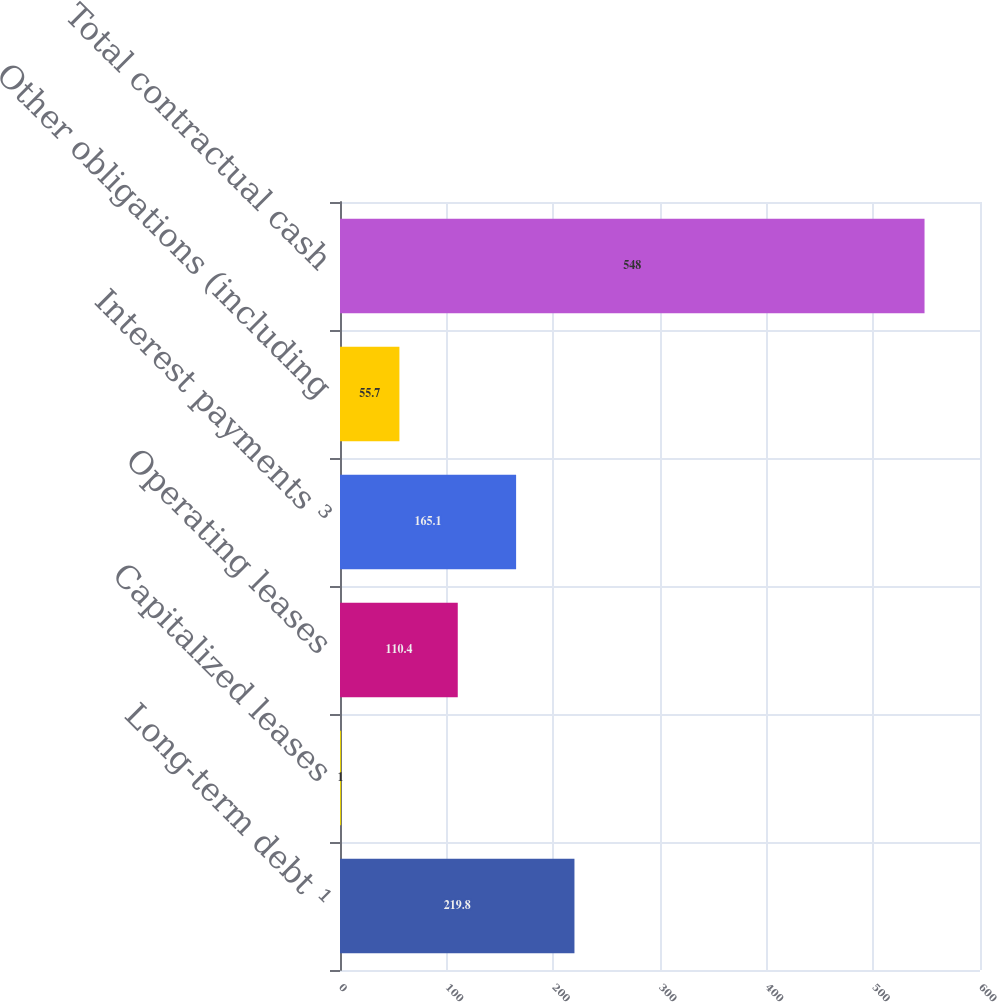<chart> <loc_0><loc_0><loc_500><loc_500><bar_chart><fcel>Long-term debt ¹<fcel>Capitalized leases<fcel>Operating leases<fcel>Interest payments ³<fcel>Other obligations (including<fcel>Total contractual cash<nl><fcel>219.8<fcel>1<fcel>110.4<fcel>165.1<fcel>55.7<fcel>548<nl></chart> 